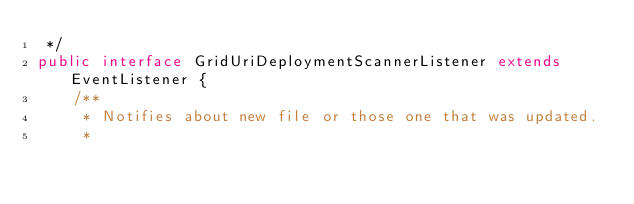<code> <loc_0><loc_0><loc_500><loc_500><_Java_> */
public interface GridUriDeploymentScannerListener extends EventListener {
    /**
     * Notifies about new file or those one that was updated.
     *</code> 